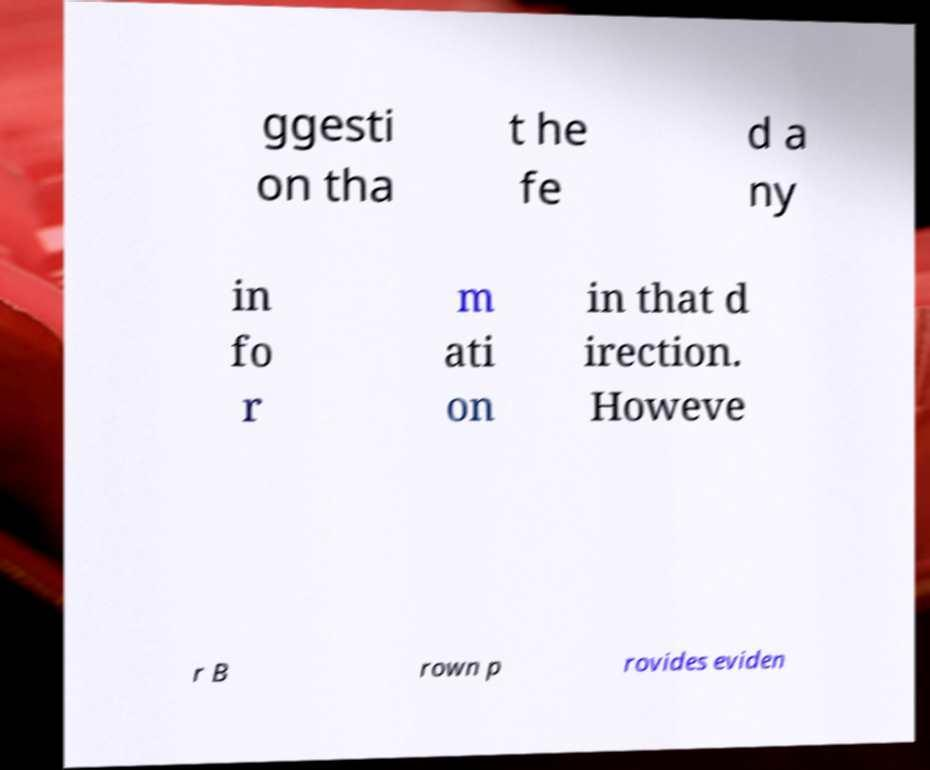Can you accurately transcribe the text from the provided image for me? ggesti on tha t he fe d a ny in fo r m ati on in that d irection. Howeve r B rown p rovides eviden 